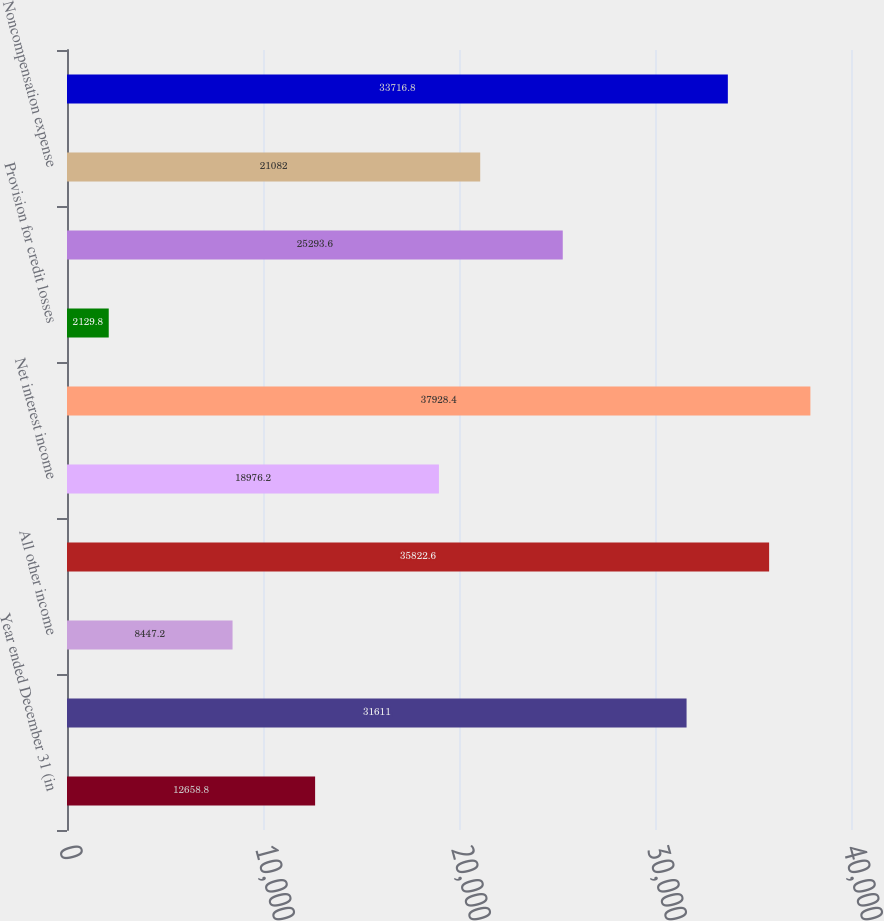<chart> <loc_0><loc_0><loc_500><loc_500><bar_chart><fcel>Year ended December 31 (in<fcel>Asset management<fcel>All other income<fcel>Noninterest revenue<fcel>Net interest income<fcel>Total net revenue<fcel>Provision for credit losses<fcel>Compensation expense<fcel>Noncompensation expense<fcel>Total noninterest expense<nl><fcel>12658.8<fcel>31611<fcel>8447.2<fcel>35822.6<fcel>18976.2<fcel>37928.4<fcel>2129.8<fcel>25293.6<fcel>21082<fcel>33716.8<nl></chart> 